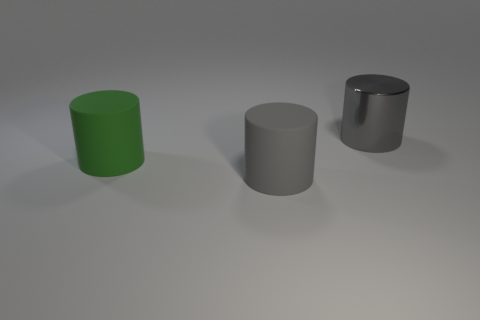Add 2 shiny cylinders. How many objects exist? 5 Add 3 big gray rubber cylinders. How many big gray rubber cylinders are left? 4 Add 1 blue metallic balls. How many blue metallic balls exist? 1 Subtract 0 red cylinders. How many objects are left? 3 Subtract all large gray metal cylinders. Subtract all gray cylinders. How many objects are left? 0 